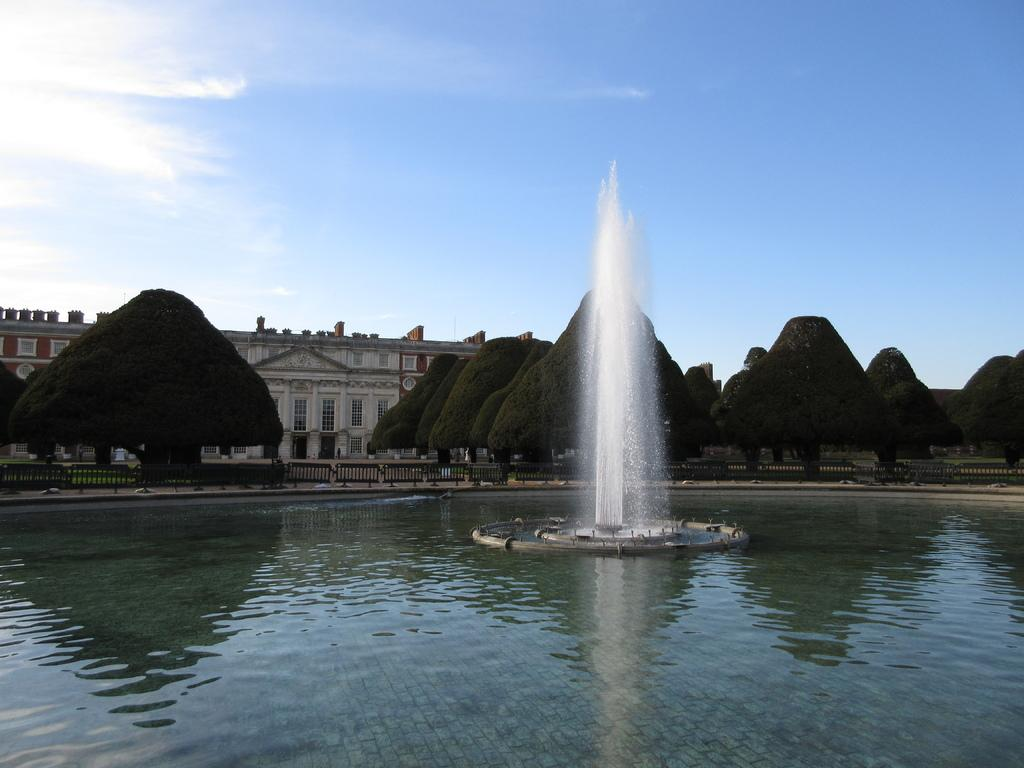What is the main element in the image? There is water in the image. What is located within the water? There is a fountain in the water. What can be seen in the background of the image? There are trees, a fence, at least one building, windows, and clouds in the sky in the background of the image. What type of watch can be seen on the fountain in the image? There is no watch present on the fountain in the image. What question is being asked by the person standing next to the fountain in the image? There is no person standing next to the fountain in the image. 